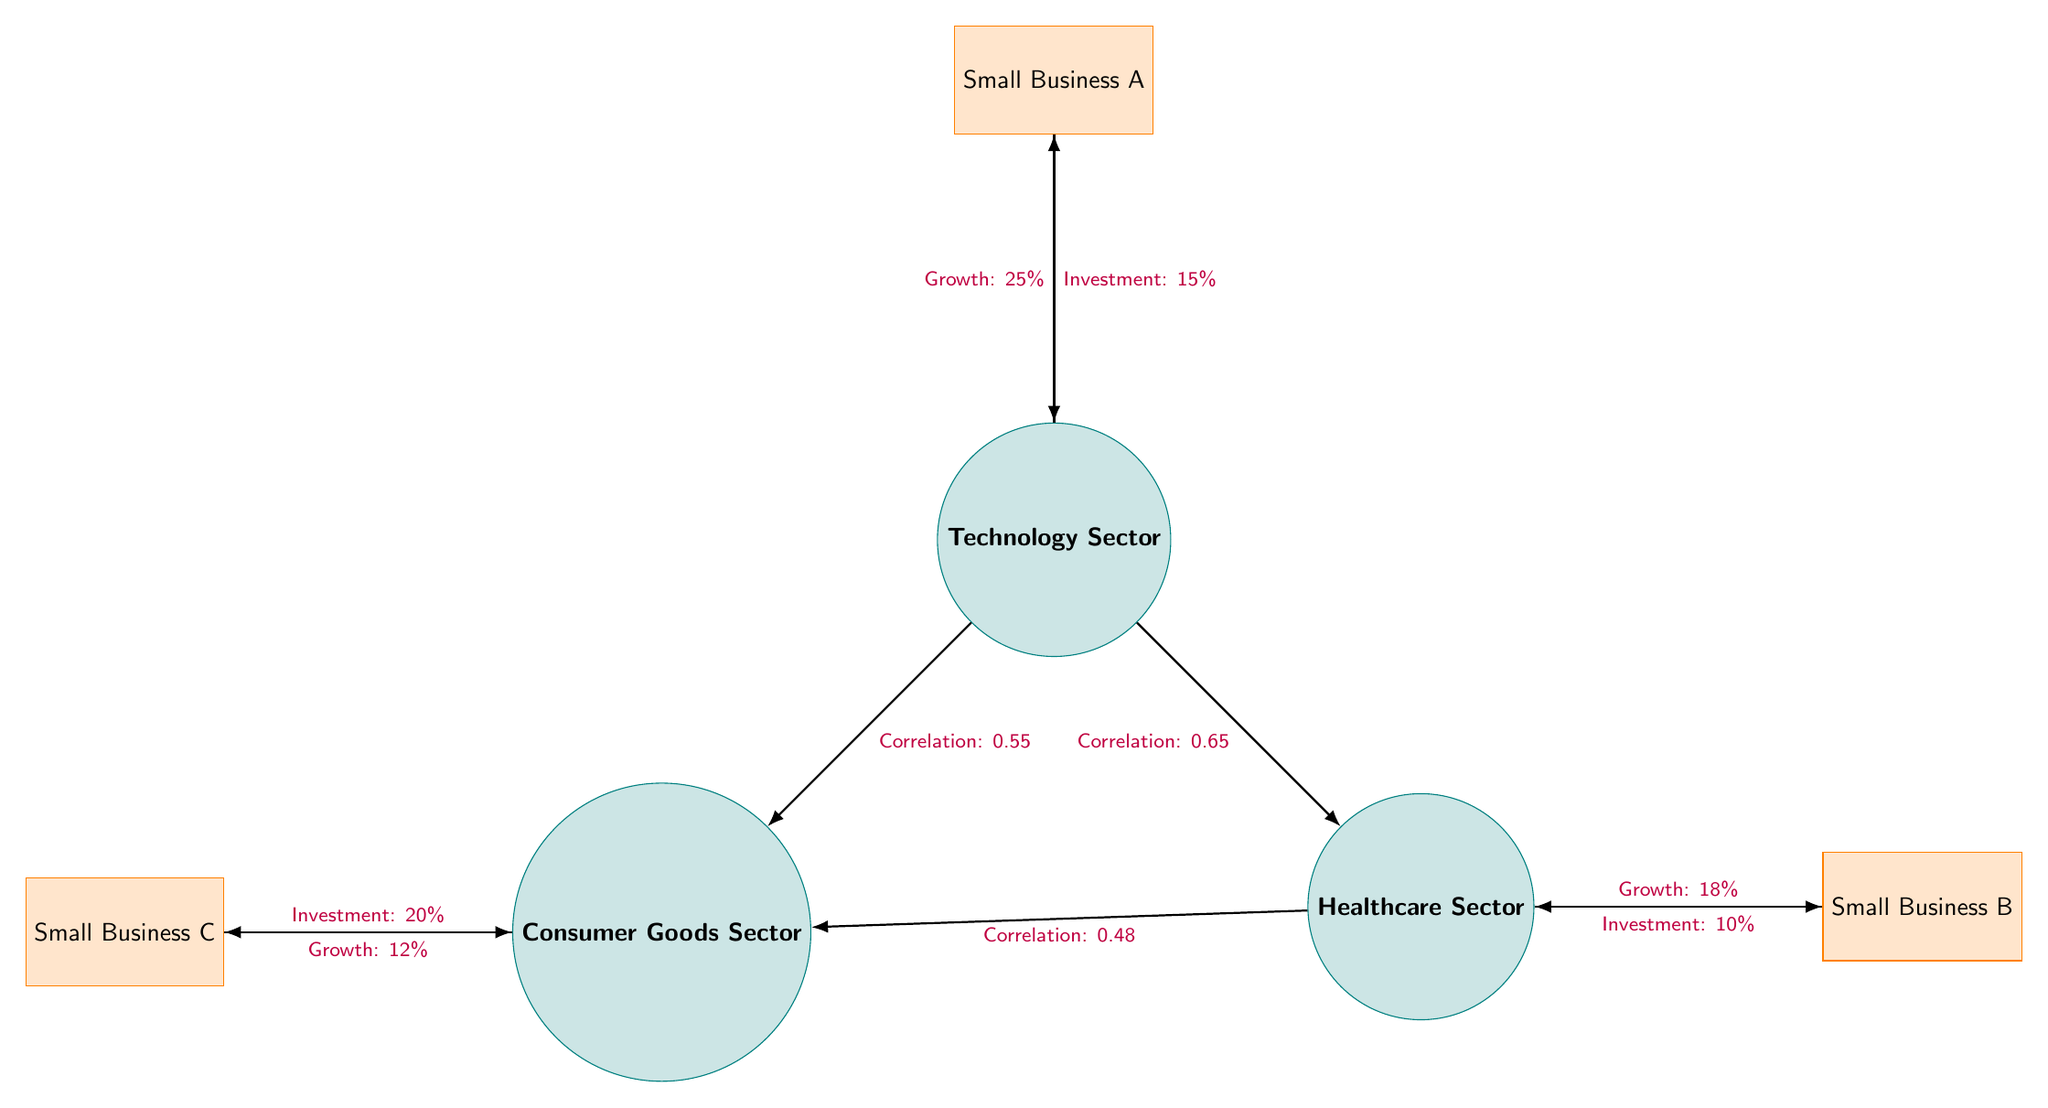What's the investment percentage for Small Business A in the Technology Sector? The diagram indicates that Small Business A has an investment of 15% directed to the Technology Sector, as shown by the edge labeled "Investment: 15%" connecting Small Business A to the Technology Sector node.
Answer: 15% What is the growth percentage associated with the Healthcare Sector? The edge from the Healthcare Sector to Small Business B is labeled "Growth: 18%," indicating that this is the growth percentage for the Healthcare Sector.
Answer: 18% How many small businesses are represented in the diagram? The diagram includes three small businesses: Small Business A, Small Business B, and Small Business C, which can be counted directly from the labeled nodes.
Answer: 3 Which sector has the highest growth rate? By comparing the growth rates associated with each sector, Technology has a growth rate of 25%, Healthcare has 18%, and Consumer Goods has 12%. Technology has the highest growth rate.
Answer: Technology Sector What is the correlation between the Technology Sector and the Consumer Goods Sector? The edge connecting the Technology Sector and the Consumer Goods Sector is labeled "Correlation: 0.55," which indicates the value of the correlation between these two sectors.
Answer: 0.55 Which small business has the highest investment percentage? By examining the investment percentages for each small business—in this case, 15% for Small Business A, 10% for Small Business B, and 20% for Small Business C—it's clear that Small Business C has the highest investment at 20%.
Answer: Small Business C What is the correlation between the Healthcare Sector and the Consumer Goods Sector? The diagram shows a correlation edge labeled "Correlation: 0.48" between the Healthcare Sector and the Consumer Goods Sector, clearly indicating this correlation value.
Answer: 0.48 Which sector shows the lowest investment percentage among the three small businesses? Analyzing the investment percentages shows that Small Business B invests 10% in the Healthcare Sector, which is lower than the investments of Small Business A and Small Business C.
Answer: Healthcare Sector 